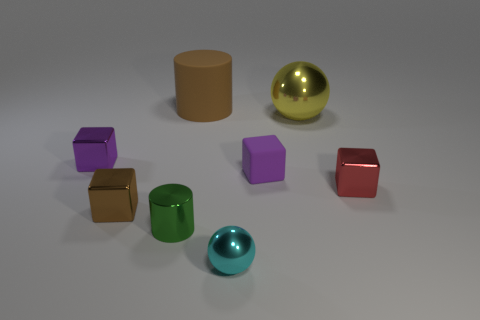What is the shape of the matte object that is the same size as the yellow metal object?
Your response must be concise. Cylinder. Are there any purple rubber things that have the same shape as the large yellow object?
Provide a succinct answer. No. What number of cyan things have the same material as the tiny red thing?
Provide a succinct answer. 1. Is the material of the big thing that is left of the yellow metal thing the same as the tiny cyan object?
Keep it short and to the point. No. Is the number of tiny purple objects to the right of the small cyan shiny thing greater than the number of tiny matte cubes that are on the right side of the red metallic object?
Make the answer very short. Yes. What material is the sphere that is the same size as the purple shiny object?
Your response must be concise. Metal. What number of other things are made of the same material as the green cylinder?
Provide a succinct answer. 5. Do the brown thing behind the big yellow thing and the purple thing to the right of the tiny purple metallic block have the same shape?
Provide a short and direct response. No. How many other objects are there of the same color as the rubber cylinder?
Offer a terse response. 1. Is the material of the small purple block on the right side of the large brown rubber thing the same as the cube on the right side of the yellow thing?
Ensure brevity in your answer.  No. 